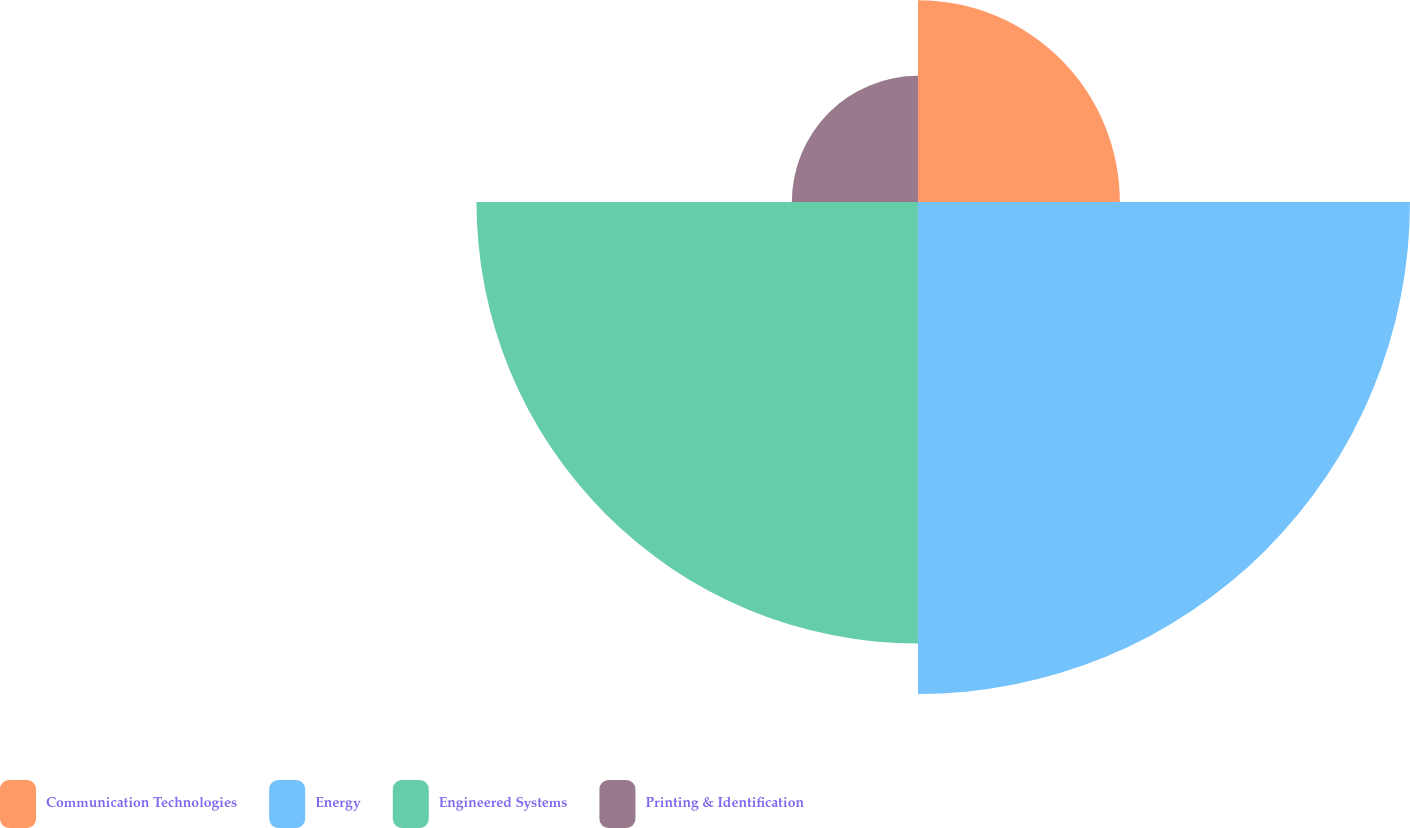<chart> <loc_0><loc_0><loc_500><loc_500><pie_chart><fcel>Communication Technologies<fcel>Energy<fcel>Engineered Systems<fcel>Printing & Identification<nl><fcel>16.0%<fcel>39.0%<fcel>35.0%<fcel>10.0%<nl></chart> 